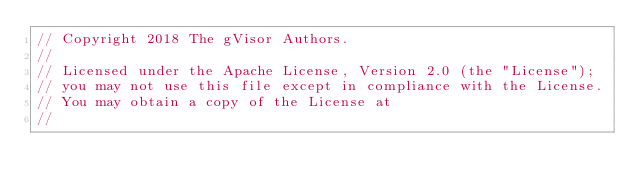Convert code to text. <code><loc_0><loc_0><loc_500><loc_500><_Go_>// Copyright 2018 The gVisor Authors.
//
// Licensed under the Apache License, Version 2.0 (the "License");
// you may not use this file except in compliance with the License.
// You may obtain a copy of the License at
//</code> 